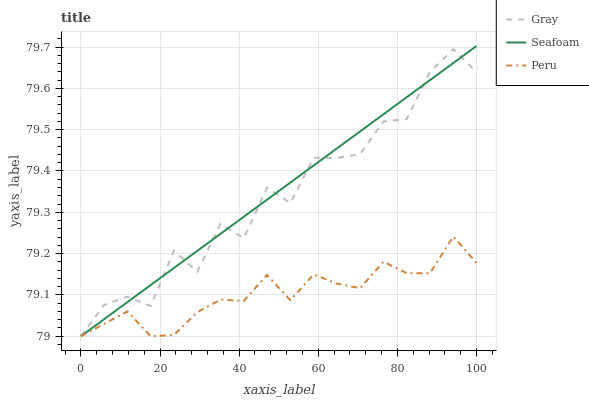Does Seafoam have the minimum area under the curve?
Answer yes or no. No. Does Peru have the maximum area under the curve?
Answer yes or no. No. Is Peru the smoothest?
Answer yes or no. No. Is Peru the roughest?
Answer yes or no. No. Does Peru have the highest value?
Answer yes or no. No. 